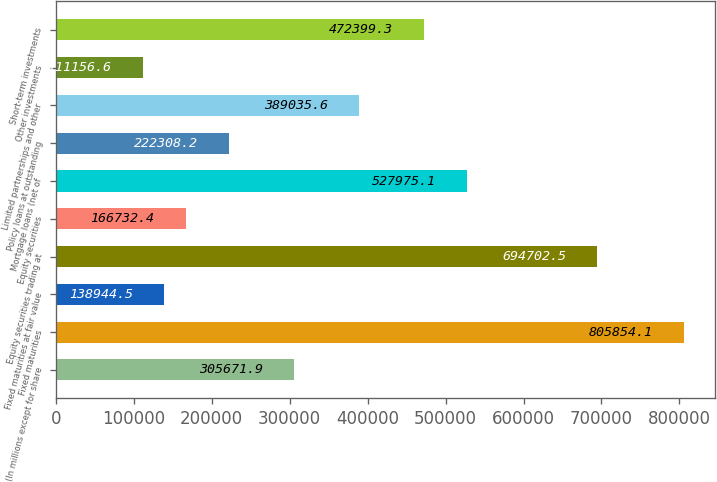<chart> <loc_0><loc_0><loc_500><loc_500><bar_chart><fcel>(In millions except for share<fcel>Fixed maturities<fcel>Fixed maturities at fair value<fcel>Equity securities trading at<fcel>Equity securities<fcel>Mortgage loans (net of<fcel>Policy loans at outstanding<fcel>Limited partnerships and other<fcel>Other investments<fcel>Short-term investments<nl><fcel>305672<fcel>805854<fcel>138944<fcel>694702<fcel>166732<fcel>527975<fcel>222308<fcel>389036<fcel>111157<fcel>472399<nl></chart> 